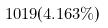<formula> <loc_0><loc_0><loc_500><loc_500>1 0 1 9 ( 4 . 1 6 3 \% )</formula> 